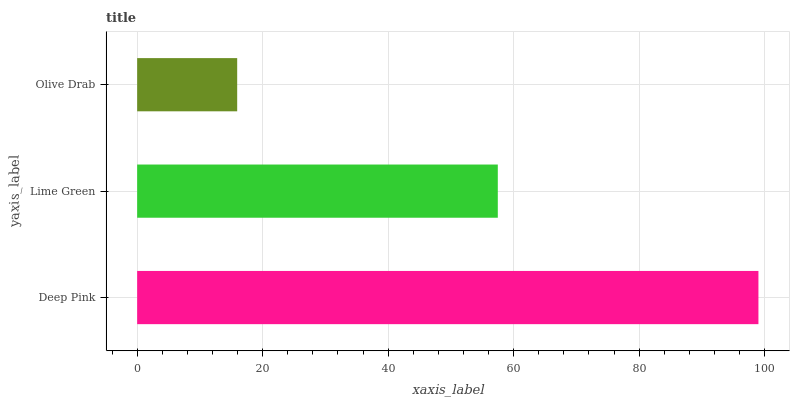Is Olive Drab the minimum?
Answer yes or no. Yes. Is Deep Pink the maximum?
Answer yes or no. Yes. Is Lime Green the minimum?
Answer yes or no. No. Is Lime Green the maximum?
Answer yes or no. No. Is Deep Pink greater than Lime Green?
Answer yes or no. Yes. Is Lime Green less than Deep Pink?
Answer yes or no. Yes. Is Lime Green greater than Deep Pink?
Answer yes or no. No. Is Deep Pink less than Lime Green?
Answer yes or no. No. Is Lime Green the high median?
Answer yes or no. Yes. Is Lime Green the low median?
Answer yes or no. Yes. Is Olive Drab the high median?
Answer yes or no. No. Is Olive Drab the low median?
Answer yes or no. No. 